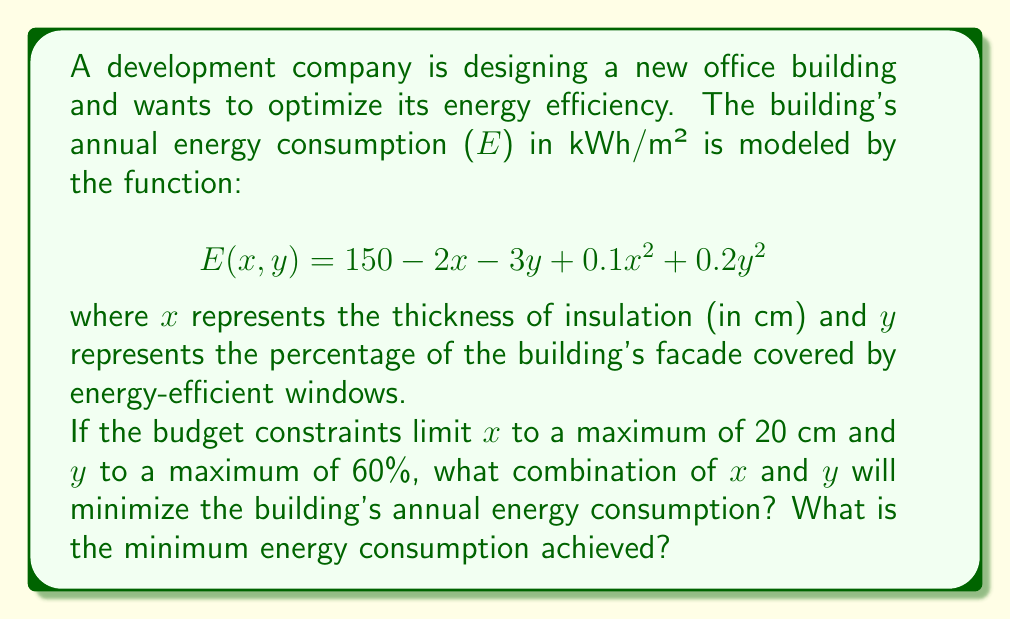Teach me how to tackle this problem. To solve this optimization problem, we need to find the minimum value of the function E(x, y) within the given constraints:

1. 0 ≤ x ≤ 20
2. 0 ≤ y ≤ 60

First, we'll find the critical points by taking partial derivatives and setting them to zero:

$$\frac{\partial E}{\partial x} = -2 + 0.2x = 0$$
$$\frac{\partial E}{\partial y} = -3 + 0.4y = 0$$

Solving these equations:
$$x = 10$$ and $$y = 7.5$$

However, y = 7.5 is outside our constraint of 0 ≤ y ≤ 60. So we need to check the boundaries of our constraints as well.

Let's evaluate E(x, y) at the following points:
1. (10, 60) - Critical x, maximum y
2. (20, 60) - Maximum x, maximum y
3. (20, 7.5) - Maximum x, critical y

1. E(10, 60) = 150 - 2(10) - 3(60) + 0.1(10)² + 0.2(60)² = 22 kWh/m²
2. E(20, 60) = 150 - 2(20) - 3(60) + 0.1(20)² + 0.2(60)² = 40 kWh/m²
3. E(20, 7.5) = 150 - 2(20) - 3(7.5) + 0.1(20)² + 0.2(7.5)² = 89.375 kWh/m²

The minimum value among these is 22 kWh/m² at (10, 60).
Answer: The optimal combination is 10 cm of insulation thickness and 60% window coverage, resulting in a minimum annual energy consumption of 22 kWh/m². 